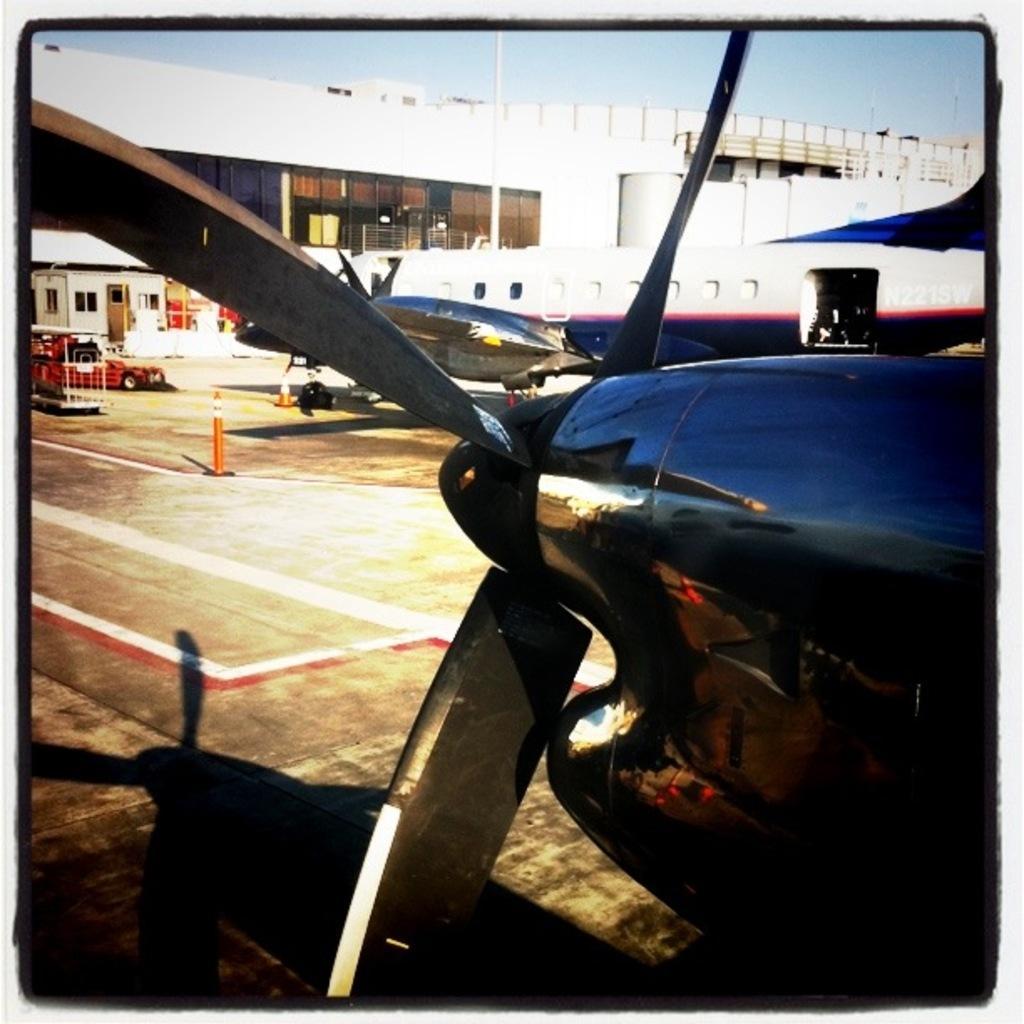Can you describe this image briefly? In this image there are few airplanes and few vehicles are on the road having few inverted cones o n it. Background there is a building having windows and doors. Top of image there is sky. 